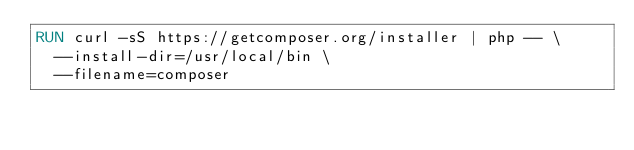Convert code to text. <code><loc_0><loc_0><loc_500><loc_500><_Dockerfile_>RUN curl -sS https://getcomposer.org/installer | php -- \
	--install-dir=/usr/local/bin \
	--filename=composer

</code> 